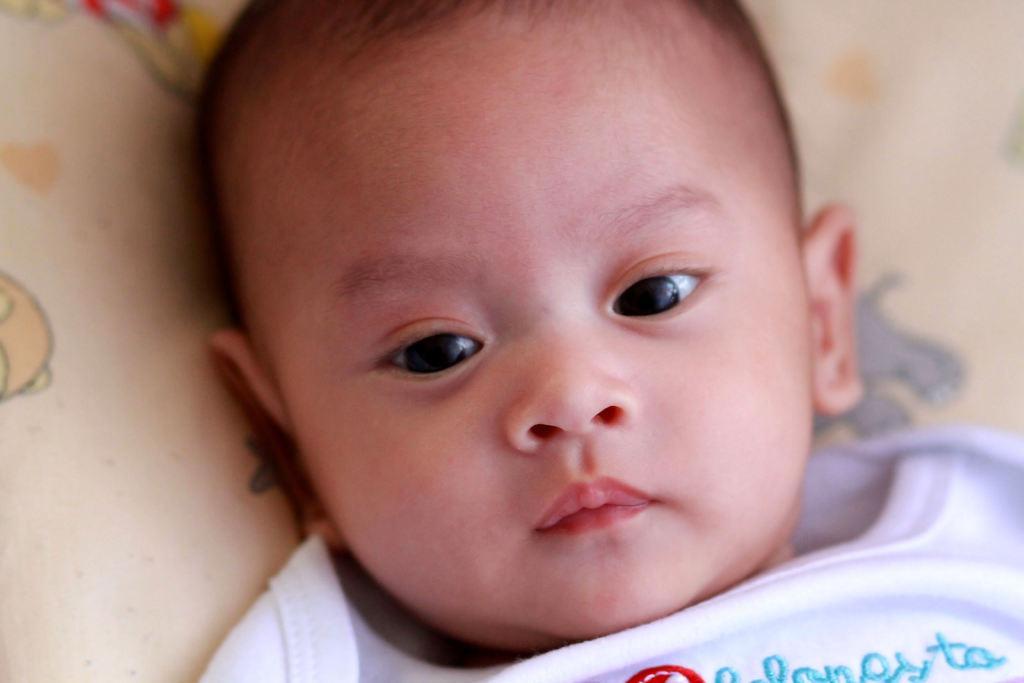Can you describe this image briefly? In the picture i can see a kid wearing white color dress lying on pillow which is of cream color. 